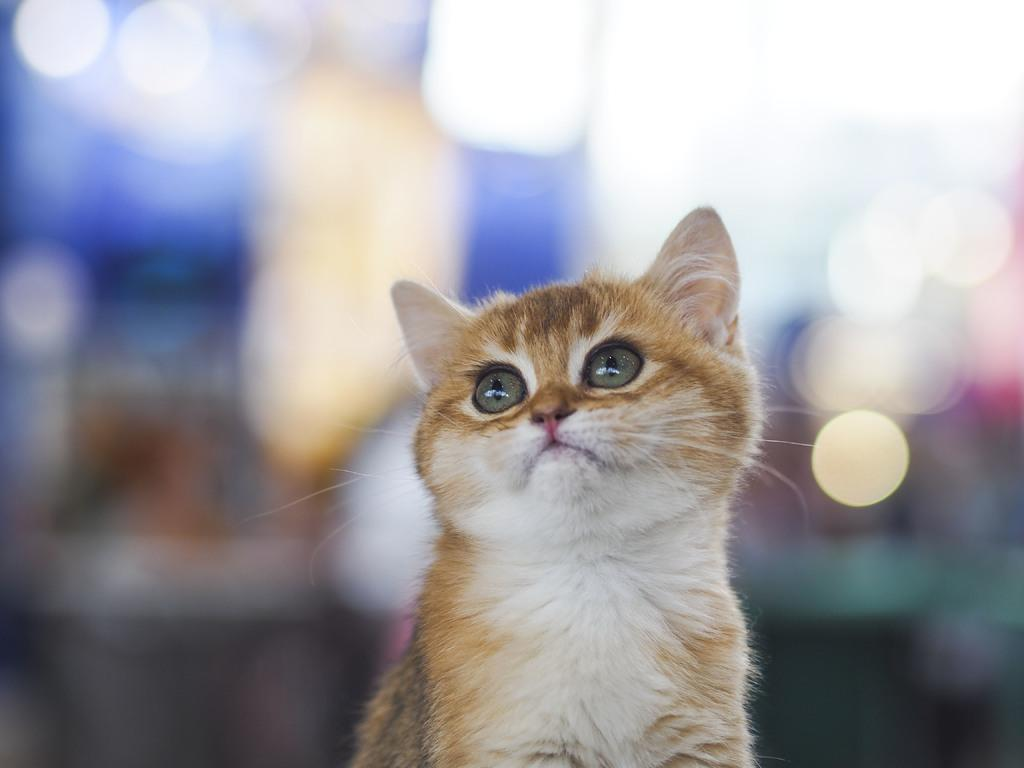What is the main subject of the image? There is a cat at the center of the image. Can you describe the background of the image? The background of the image is blurry. How many grapes are on the chair next to the cat in the image? There are no grapes or chairs present in the image; it features a cat with a blurry background. 